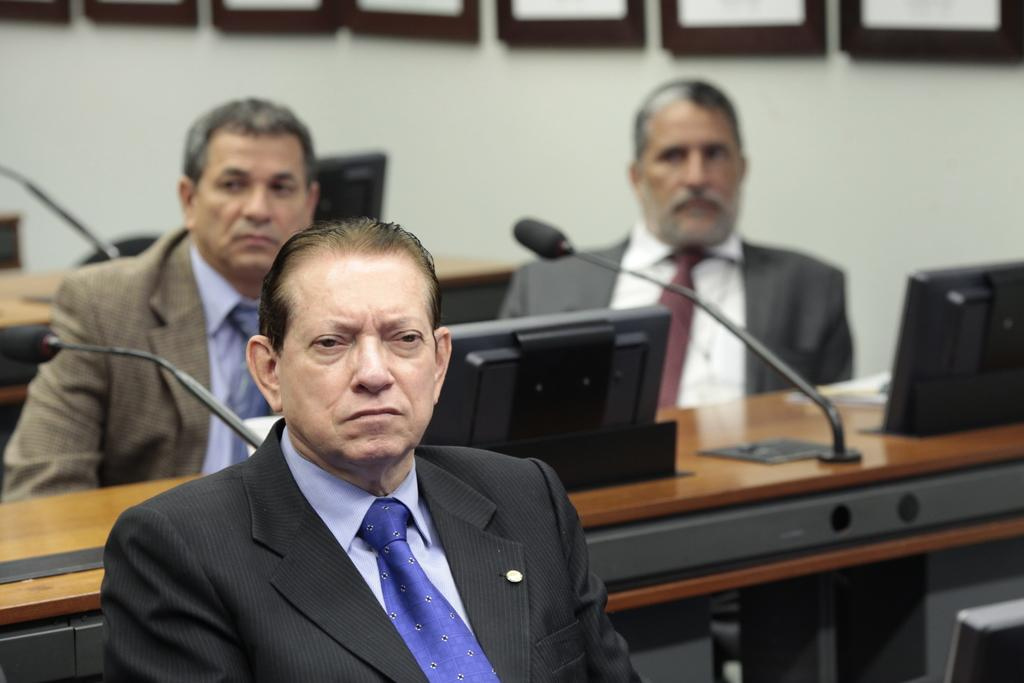How many men are in the image? There are three men in the image. What are the men doing in the image? The men are sitting on chairs. What else can be seen in the image besides the men? There are tables, mice, an electronic device, and a wall in the background. What type of knot is being tied by the men in the image? There is no knot-tying activity depicted in the image; the men are sitting on chairs. 